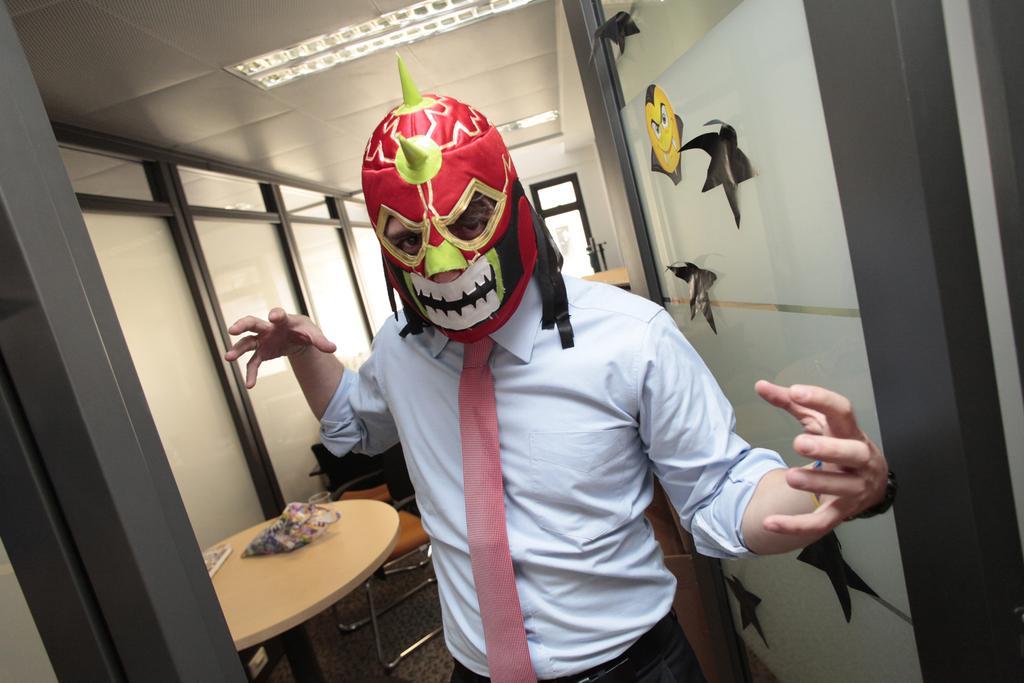Could you give a brief overview of what you see in this image? In this picture we can see a person in a mask. Behind the person, there is a chair, table and some objects. On the right side of the image, there are stickers on the glass. At the top of the image, there are ceiling lights. 